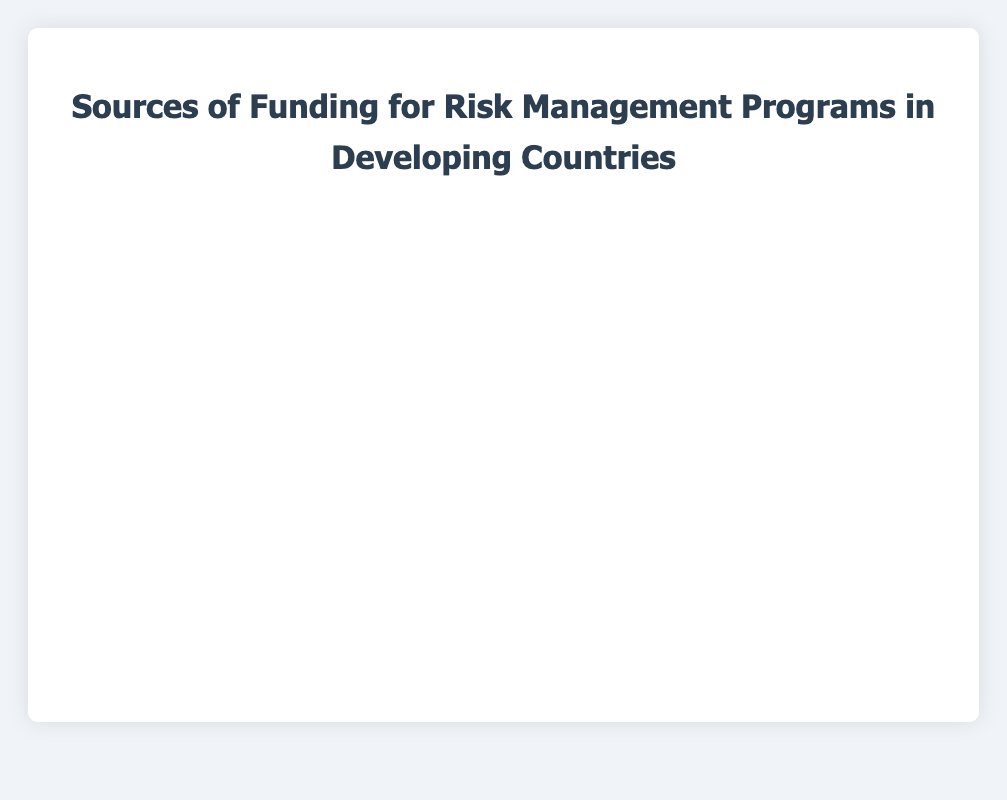Which funding source contributes the highest percentage to risk management programs in developing countries? The figure shows that the World Bank has the highest bar, representing a larger funding percentage compared to other sources.
Answer: World Bank Which two funding sources combined contribute the same percentage as the World Bank? The World Bank contributes 25%. The combination of the International Monetary Fund (IMF) (20%) and Public Donations (5%) sums to 25%, matching the World Bank's contribution.
Answer: International Monetary Fund (IMF) and Public Donations What is the difference in percentage between the funding from Bilateral Aid Agencies and Private Sector Funding? Bilateral Aid Agencies contribute 10% and Private Sector Funding contributes 12%. The difference is 12% - 10% = 2%.
Answer: 2% How does the funding from United Nations Development Programme (UNDP) compare to the funding from Private Sector Funding? UNDP contributes 15% and Private Sector Funding 12%. Visually, the bar for UNDP is longer than the bar for Private Sector Funding, showing that UNDP provides more.
Answer: UNDP provides more Which funding source is represented by the smallest bar? The smallest bar on the chart represents Public Donations, indicating it provides the least percentage of funding at 2%.
Answer: Public Donations What is the combined funding percentage from Non-Governmental Organizations (NGOs), Philanthropic Foundations, and Local Government Funding? NGOs contribute 8%, Philanthropic Foundations 5%, and Local Government Funding 3%. Combined, they contribute 8% + 5% + 3% = 16%.
Answer: 16% Is the funding percentage from the International Monetary Fund (IMF) greater than or less than the funding percentage from UNDP? Comparing the bars, IMF contributes 20% whereas UNDP contributes 15%. The IMF bar is longer, indicating a greater contribution.
Answer: Greater Which funding source has a longer bar: Bilateral Aid Agencies or Local Government Funding? Bilateral Aid Agencies contribute 10% and Local Government Funding 3%. The bar for Bilateral Aid Agencies is longer.
Answer: Bilateral Aid Agencies What is the average funding percentage of International Monetary Fund (IMF), Private Sector Funding, and Non-Governmental Organizations (NGOs)? The percentages are IMF (20%), Private Sector Funding (12%), and NGOs (8%). The average is (20 + 12 + 8) / 3 = 40 / 3 ≈ 13.33%.
Answer: Approximately 13.33% What is the median funding percentage? When the percentages are sorted: 2%, 3%, 5%, 8%, 10%, 12%, 15%, 20%, 25%. The middle value (5th) in this sorted list is 10%.
Answer: 10% 